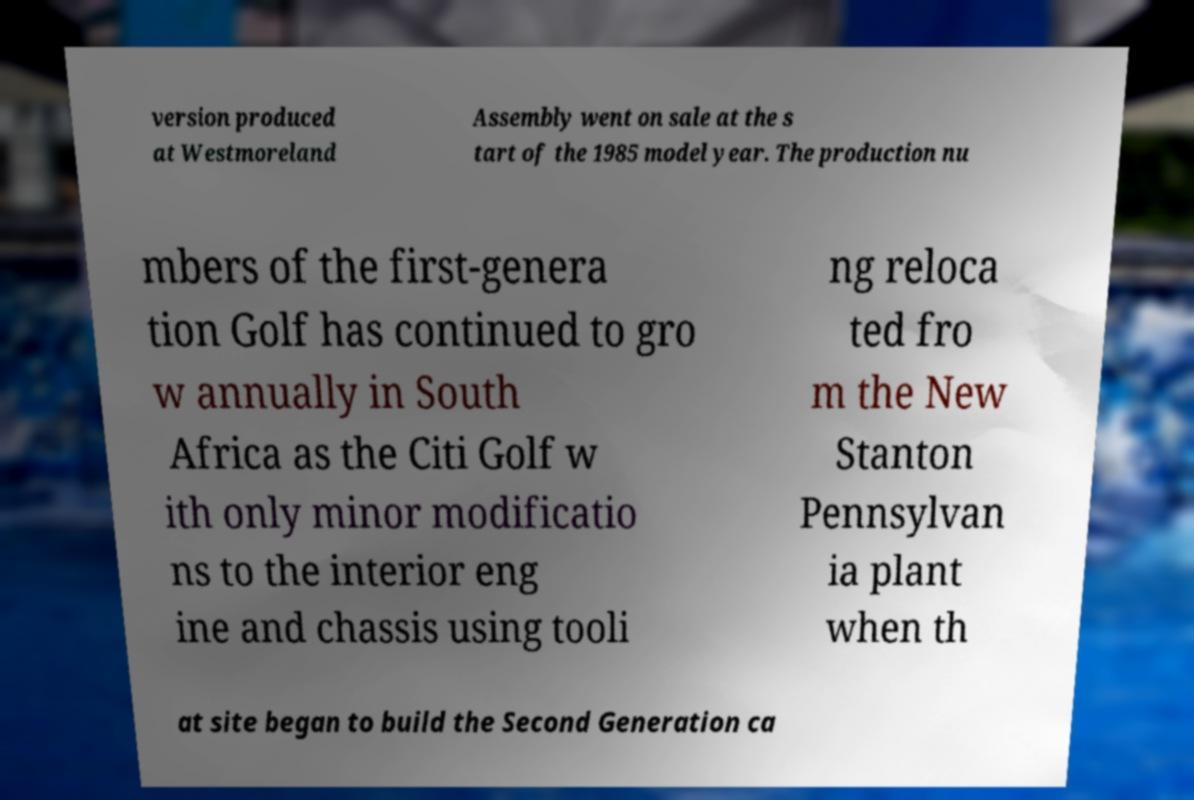Please identify and transcribe the text found in this image. version produced at Westmoreland Assembly went on sale at the s tart of the 1985 model year. The production nu mbers of the first-genera tion Golf has continued to gro w annually in South Africa as the Citi Golf w ith only minor modificatio ns to the interior eng ine and chassis using tooli ng reloca ted fro m the New Stanton Pennsylvan ia plant when th at site began to build the Second Generation ca 